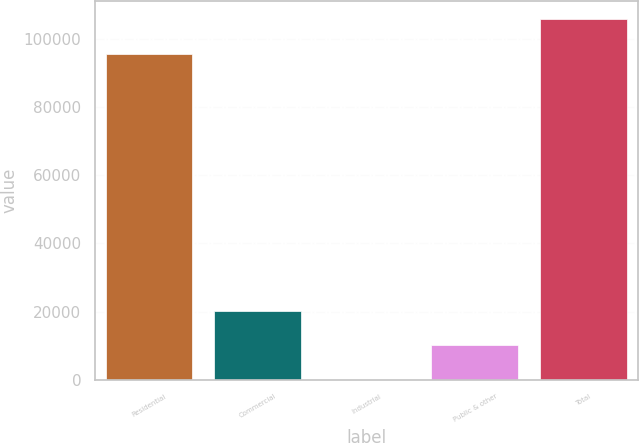Convert chart to OTSL. <chart><loc_0><loc_0><loc_500><loc_500><bar_chart><fcel>Residential<fcel>Commercial<fcel>Industrial<fcel>Public & other<fcel>Total<nl><fcel>95576<fcel>20267.2<fcel>12<fcel>10139.6<fcel>105704<nl></chart> 